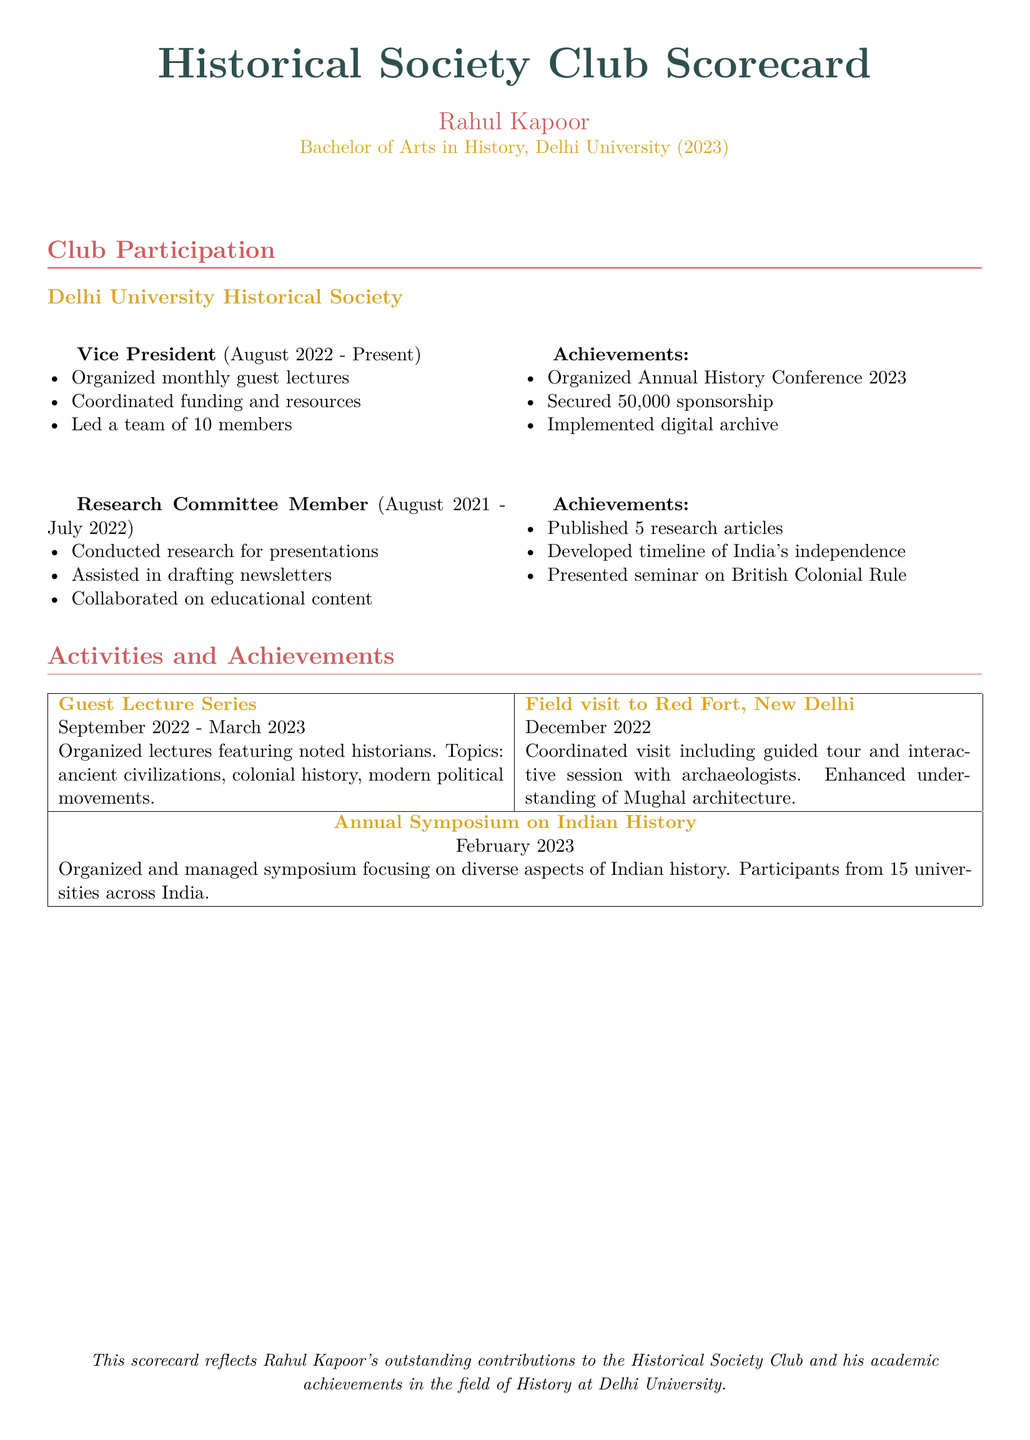What is the role of Rahul Kapoor in the Delhi University Historical Society? Rahul Kapoor serves as the Vice President of the Delhi University Historical Society.
Answer: Vice President When did Rahul Kapoor start his role as Vice President? Rahul Kapoor became Vice President in August 2022.
Answer: August 2022 What achievement is listed under his Vice President role? One of the achievements is securing ₹50,000 sponsorship.
Answer: ₹50,000 sponsorship How many research articles did Rahul Kapoor publish as a Research Committee Member? Rahul Kapoor published 5 research articles during his time as a Research Committee Member.
Answer: 5 What activity was organized between September 2022 and March 2023? The Guest Lecture Series was organized during this timeframe.
Answer: Guest Lecture Series In which month and year was the Annual Symposium on Indian History held? The Annual Symposium on Indian History took place in February 2023.
Answer: February 2023 What event featured a field visit to the Red Fort? The field visit to the Red Fort was part of a coordinated event in December 2022.
Answer: Field visit to Red Fort How many universities participated in the Annual Symposium on Indian History? The symposium had participants from 15 universities across India.
Answer: 15 What does the scorecard reflect about Rahul Kapoor's contributions? The scorecard reflects his outstanding contributions to the Historical Society Club.
Answer: Outstanding contributions 